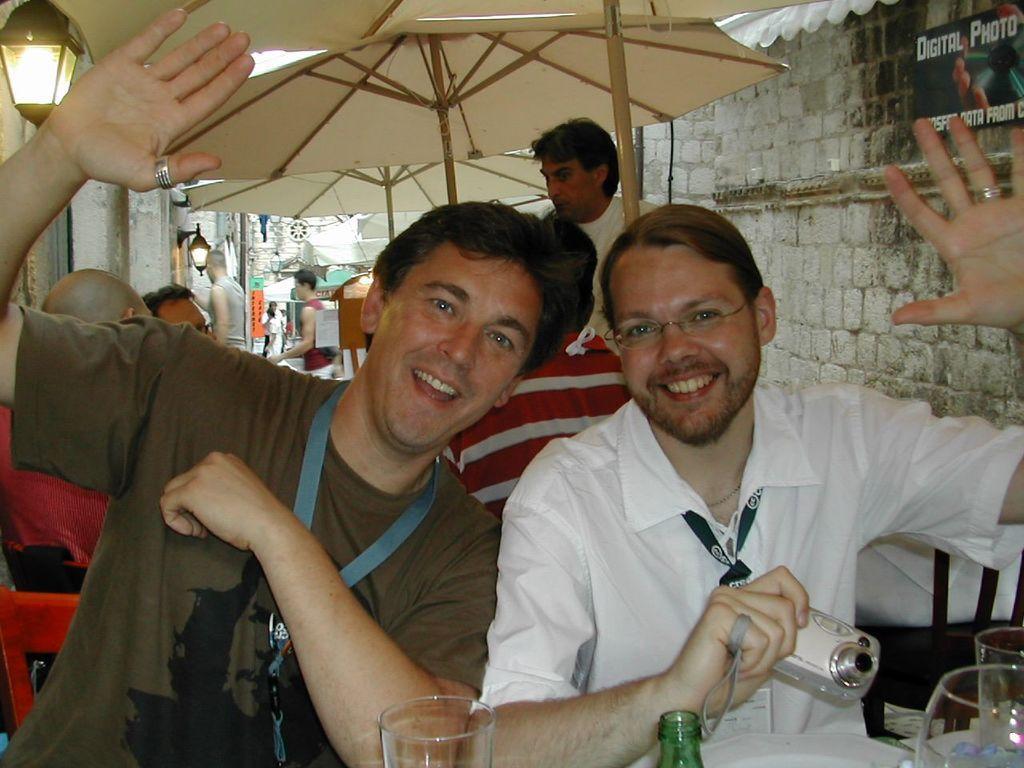How would you summarize this image in a sentence or two? On the left side, there is a person sitting, smiling and showing a hand. On the right side, there is a person in a white color shirt, holding a camera with a hand, smiling and showing other hand. In the background, there are umbrellas arranged, there is a poster attached to the wall of a building, there are lights, other persons and other buildings. 